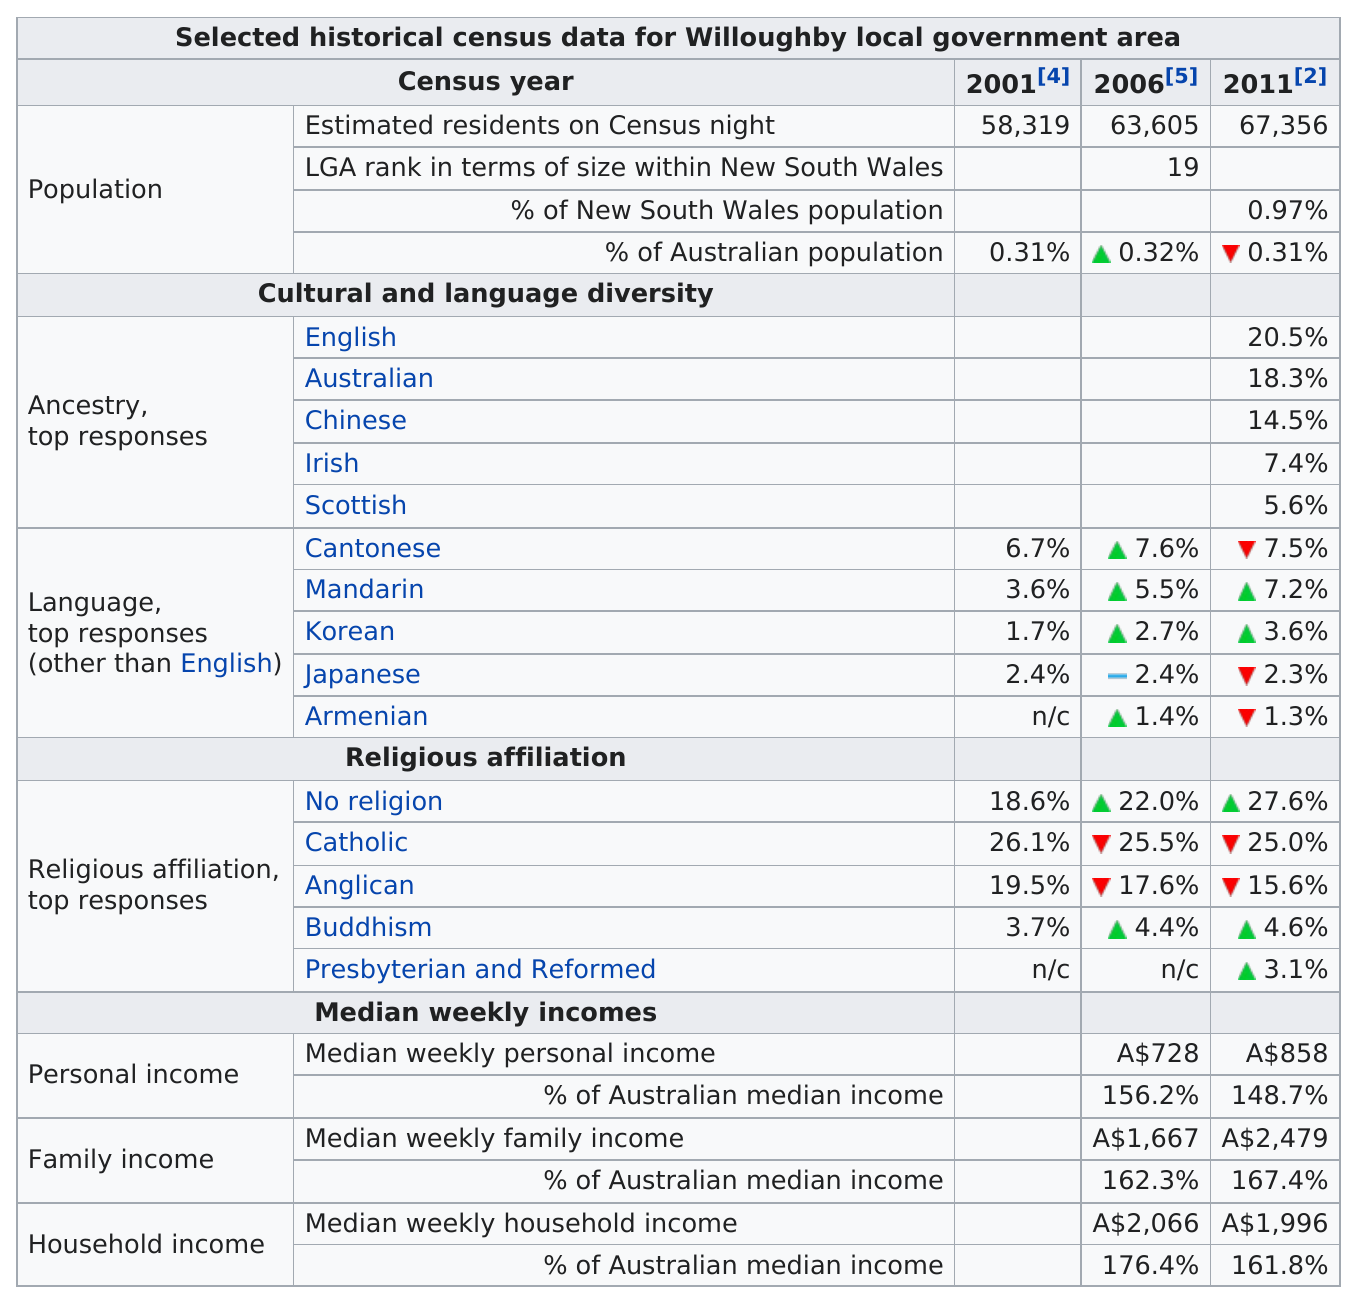Indicate a few pertinent items in this graphic. In 2011, the ancestry of the individual was 7.4% Irish. According to the data, from 2001 to 2011, the percentage of individuals reporting no religious affiliation increased by 9%. The Cantonese speaking population increased by 0.9% from 2001 to 2006. 